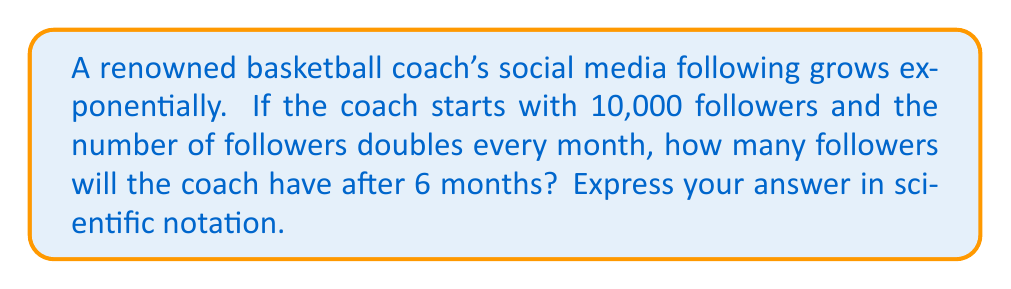Give your solution to this math problem. Let's approach this step-by-step:

1) The initial number of followers is 10,000.

2) The number of followers doubles every month, which means it's multiplied by 2 each month.

3) After 6 months, the number of followers will have doubled 6 times.

4) We can express this mathematically as:

   $10,000 \times 2^6$

5) Let's calculate $2^6$ first:
   $2^6 = 2 \times 2 \times 2 \times 2 \times 2 \times 2 = 64$

6) Now we have:
   $10,000 \times 64 = 640,000$

7) To express this in scientific notation, we move the decimal point 5 places to the left:

   $640,000 = 6.4 \times 10^5$

Therefore, after 6 months, the coach will have $6.4 \times 10^5$ followers.
Answer: $6.4 \times 10^5$ 